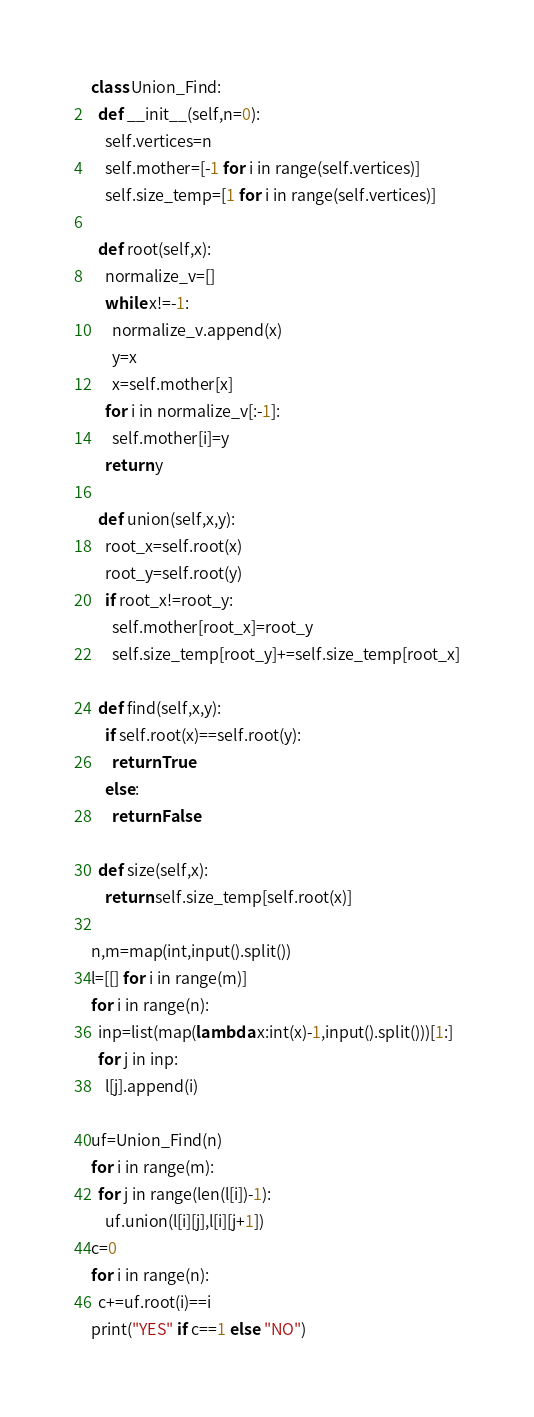<code> <loc_0><loc_0><loc_500><loc_500><_Python_>class Union_Find:
  def __init__(self,n=0):
    self.vertices=n
    self.mother=[-1 for i in range(self.vertices)]
    self.size_temp=[1 for i in range(self.vertices)]
  
  def root(self,x):
    normalize_v=[]
    while x!=-1:
      normalize_v.append(x)
      y=x
      x=self.mother[x]
    for i in normalize_v[:-1]:
      self.mother[i]=y
    return y
  
  def union(self,x,y):
    root_x=self.root(x)
    root_y=self.root(y)
    if root_x!=root_y:
      self.mother[root_x]=root_y
      self.size_temp[root_y]+=self.size_temp[root_x]
  
  def find(self,x,y):
    if self.root(x)==self.root(y):
      return True
    else:
      return False
  
  def size(self,x):
    return self.size_temp[self.root(x)]
  
n,m=map(int,input().split())
l=[[] for i in range(m)]
for i in range(n):
  inp=list(map(lambda x:int(x)-1,input().split()))[1:]
  for j in inp:
    l[j].append(i)

uf=Union_Find(n)
for i in range(m):
  for j in range(len(l[i])-1):
    uf.union(l[i][j],l[i][j+1])
c=0
for i in range(n):
  c+=uf.root(i)==i
print("YES" if c==1 else "NO")</code> 